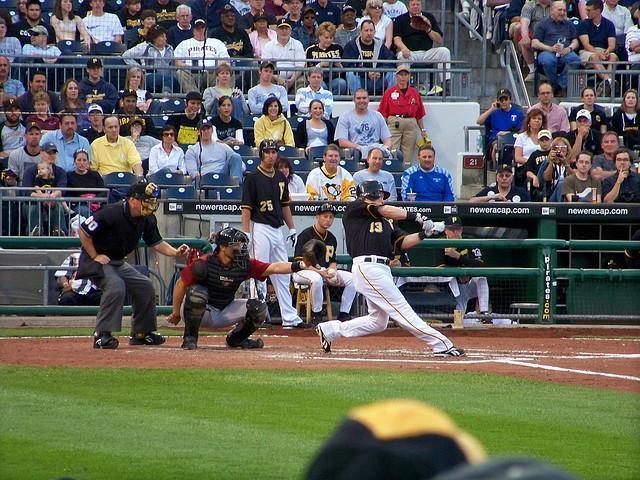How many people are in the photo?
Give a very brief answer. 8. 